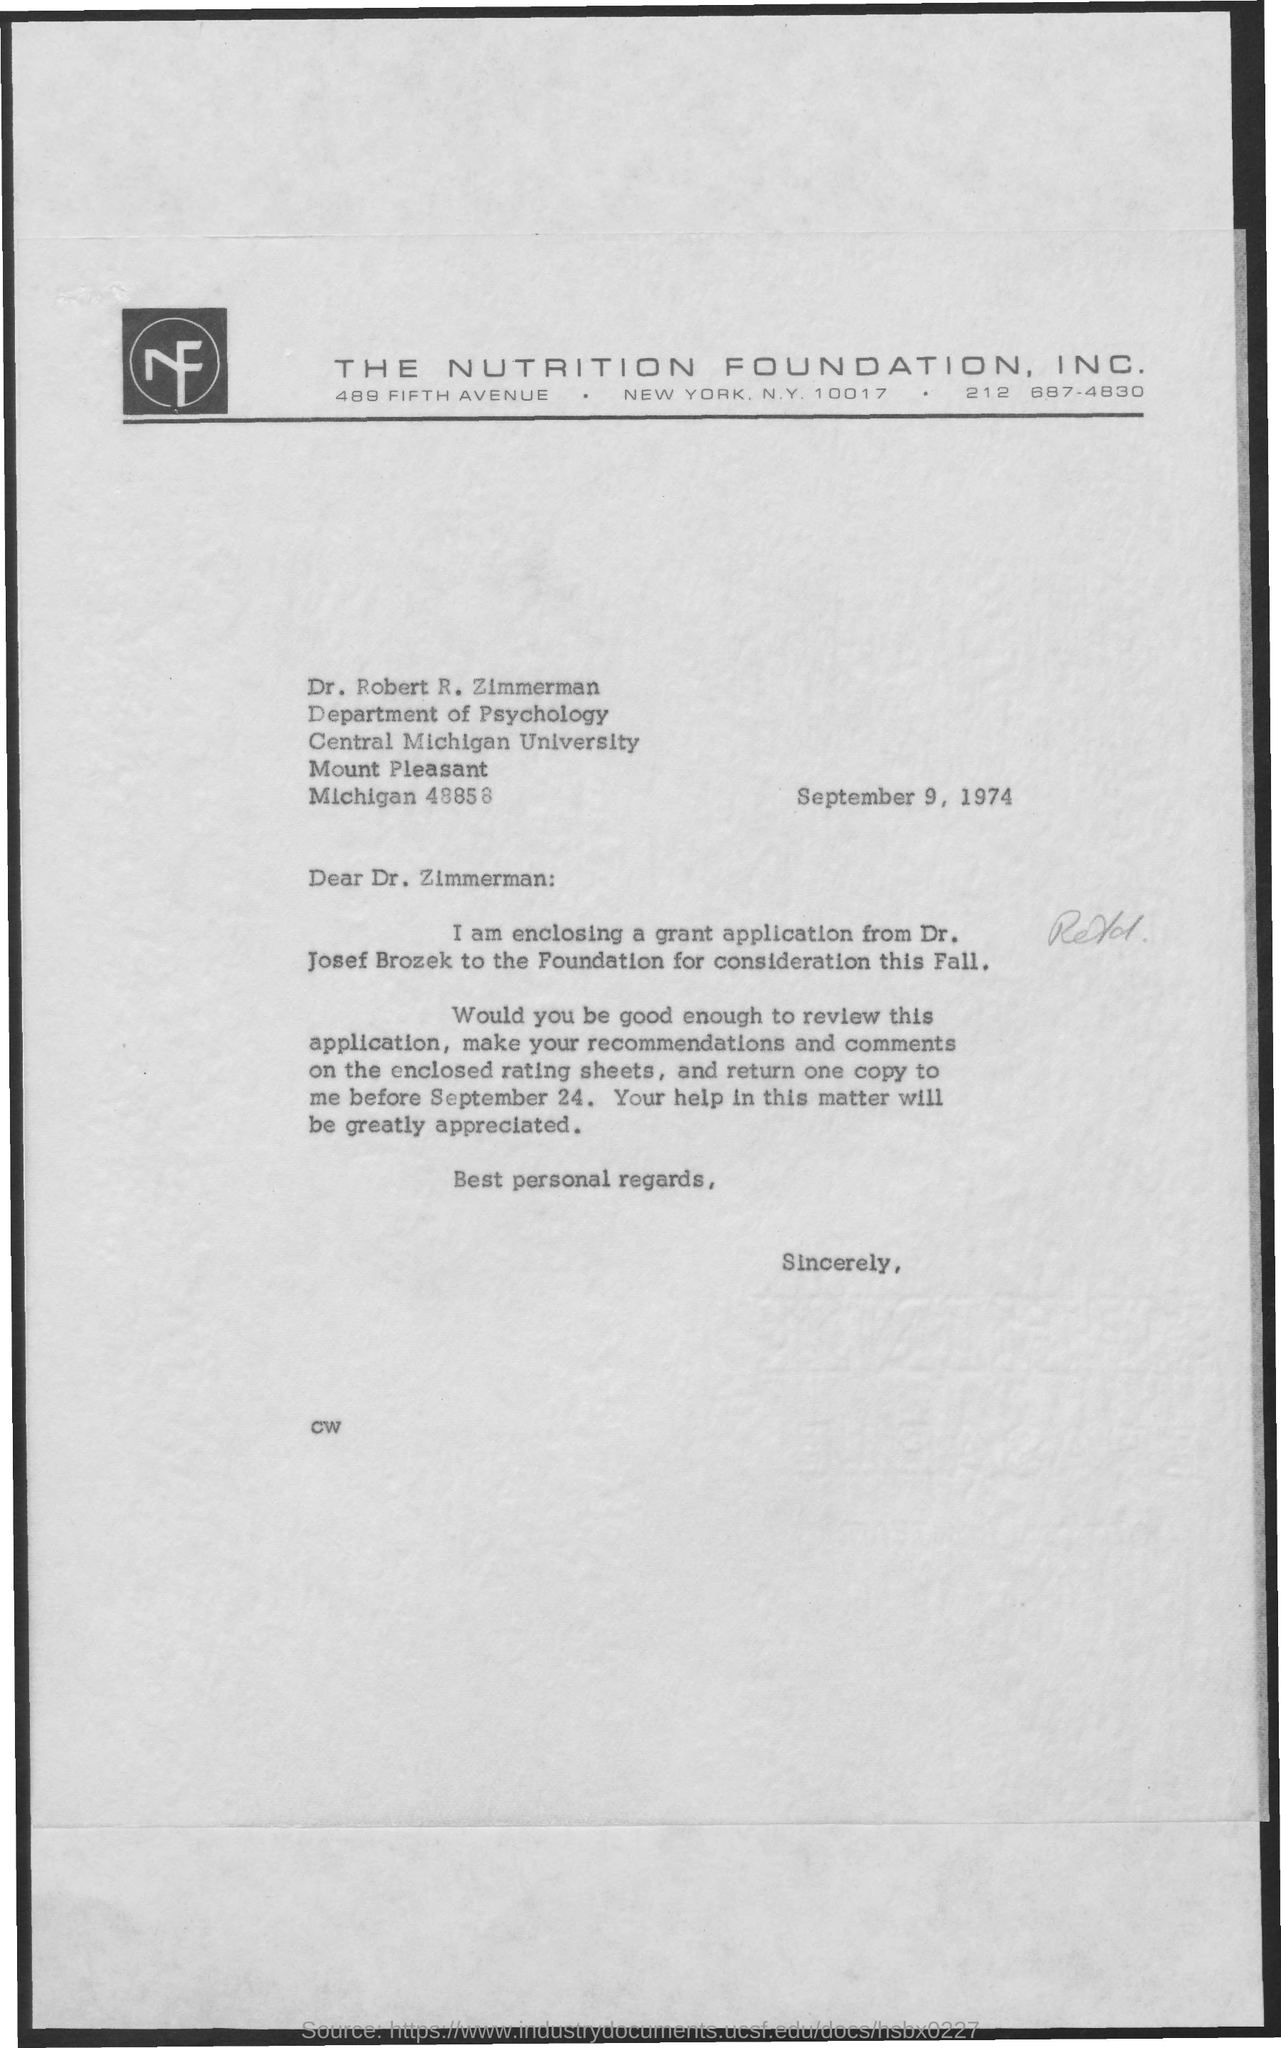Give some essential details in this illustration. The date mentioned in the letter is September 9, 1974. Dr. Robert R. Zimmerman works in the Department of Psychology. The company mentioned in the letter head is THE NUTRITION FOUNDATION, INC... 